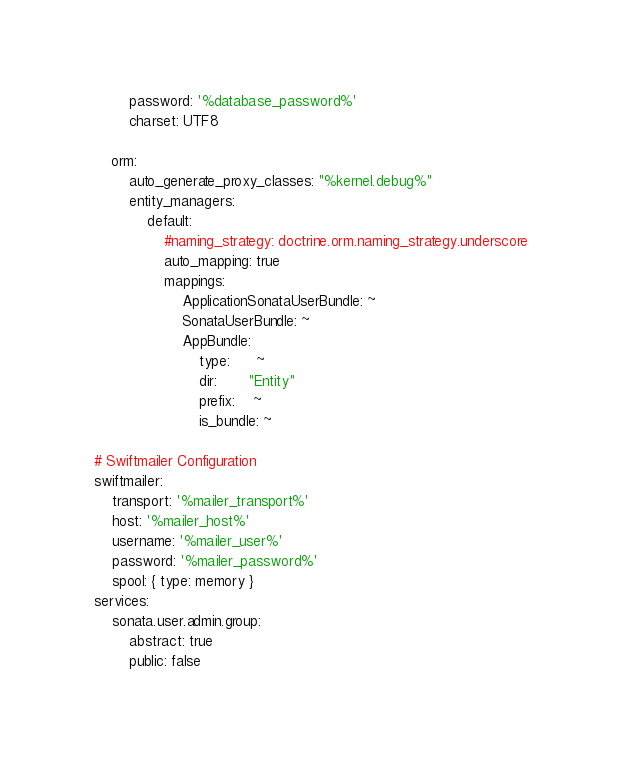Convert code to text. <code><loc_0><loc_0><loc_500><loc_500><_YAML_>        password: '%database_password%'
        charset: UTF8

    orm:
        auto_generate_proxy_classes: "%kernel.debug%"
        entity_managers:
            default:
                #naming_strategy: doctrine.orm.naming_strategy.underscore
                auto_mapping: true
                mappings:
                    ApplicationSonataUserBundle: ~
                    SonataUserBundle: ~
                    AppBundle:
                        type:      ~
                        dir:       "Entity"
                        prefix:    ~
                        is_bundle: ~

# Swiftmailer Configuration
swiftmailer:
    transport: '%mailer_transport%'
    host: '%mailer_host%'
    username: '%mailer_user%'
    password: '%mailer_password%'
    spool: { type: memory }
services:
    sonata.user.admin.group:
        abstract: true
        public: false</code> 